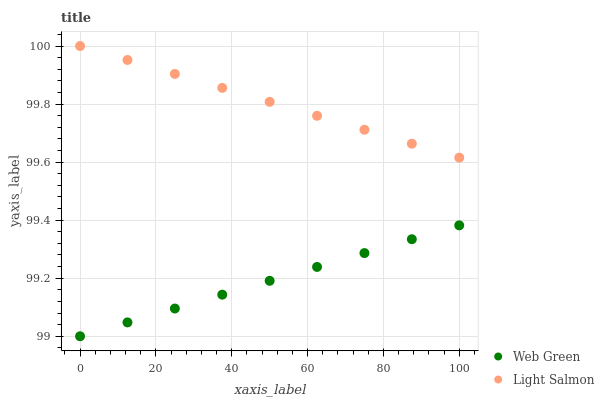Does Web Green have the minimum area under the curve?
Answer yes or no. Yes. Does Light Salmon have the maximum area under the curve?
Answer yes or no. Yes. Does Web Green have the maximum area under the curve?
Answer yes or no. No. Is Light Salmon the smoothest?
Answer yes or no. Yes. Is Web Green the roughest?
Answer yes or no. Yes. Is Web Green the smoothest?
Answer yes or no. No. Does Web Green have the lowest value?
Answer yes or no. Yes. Does Light Salmon have the highest value?
Answer yes or no. Yes. Does Web Green have the highest value?
Answer yes or no. No. Is Web Green less than Light Salmon?
Answer yes or no. Yes. Is Light Salmon greater than Web Green?
Answer yes or no. Yes. Does Web Green intersect Light Salmon?
Answer yes or no. No. 